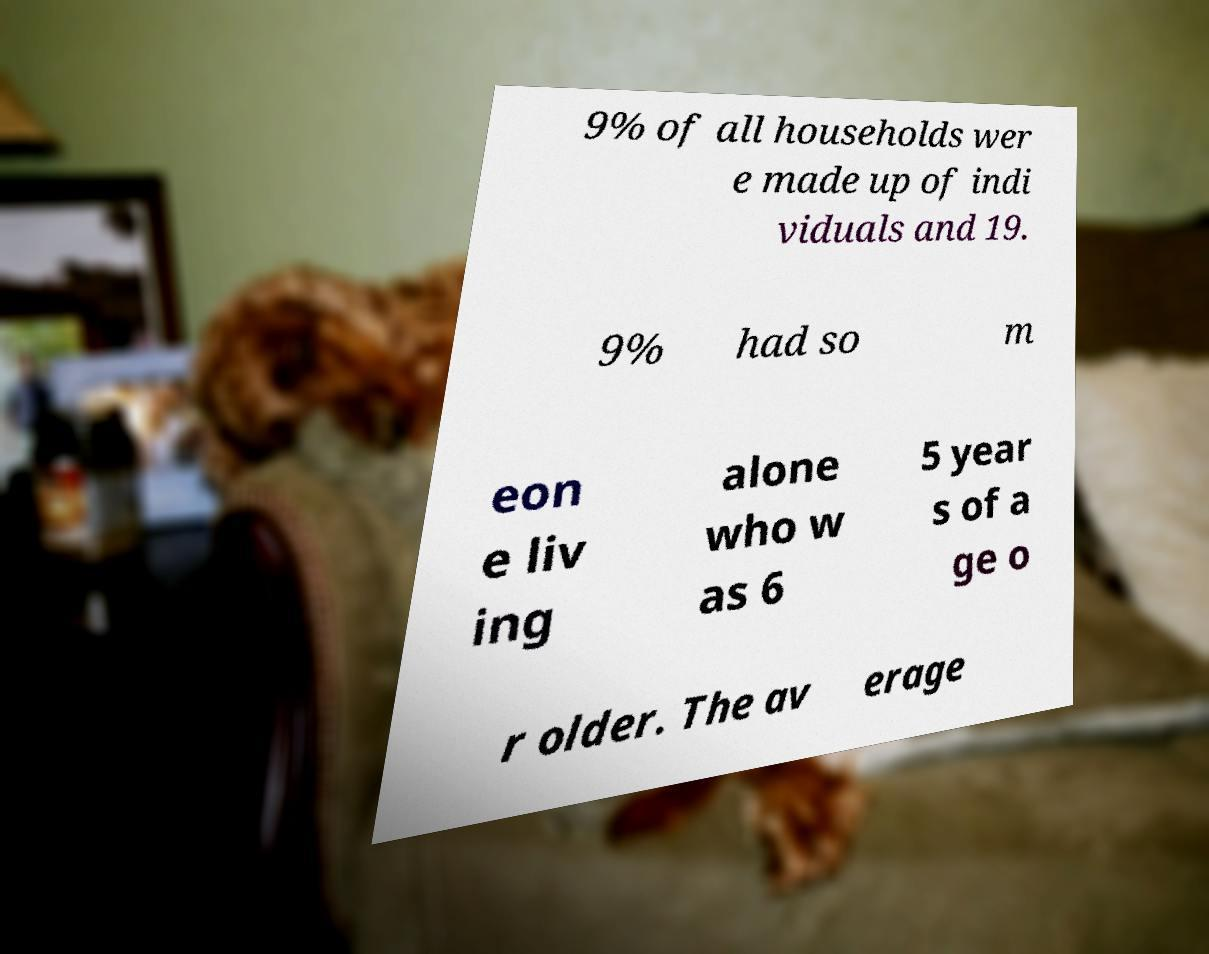Can you read and provide the text displayed in the image?This photo seems to have some interesting text. Can you extract and type it out for me? 9% of all households wer e made up of indi viduals and 19. 9% had so m eon e liv ing alone who w as 6 5 year s of a ge o r older. The av erage 